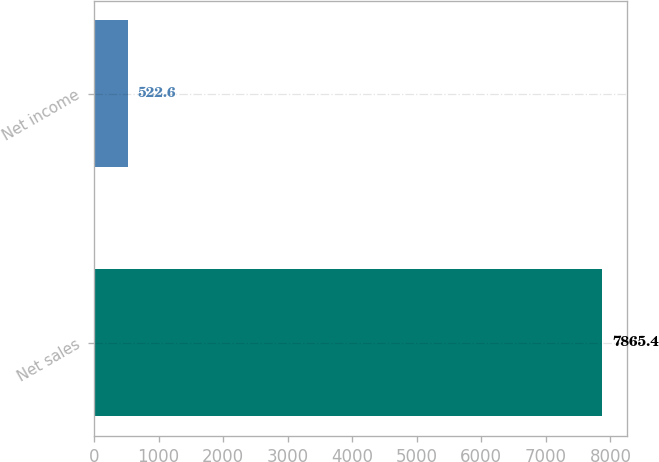Convert chart. <chart><loc_0><loc_0><loc_500><loc_500><bar_chart><fcel>Net sales<fcel>Net income<nl><fcel>7865.4<fcel>522.6<nl></chart> 